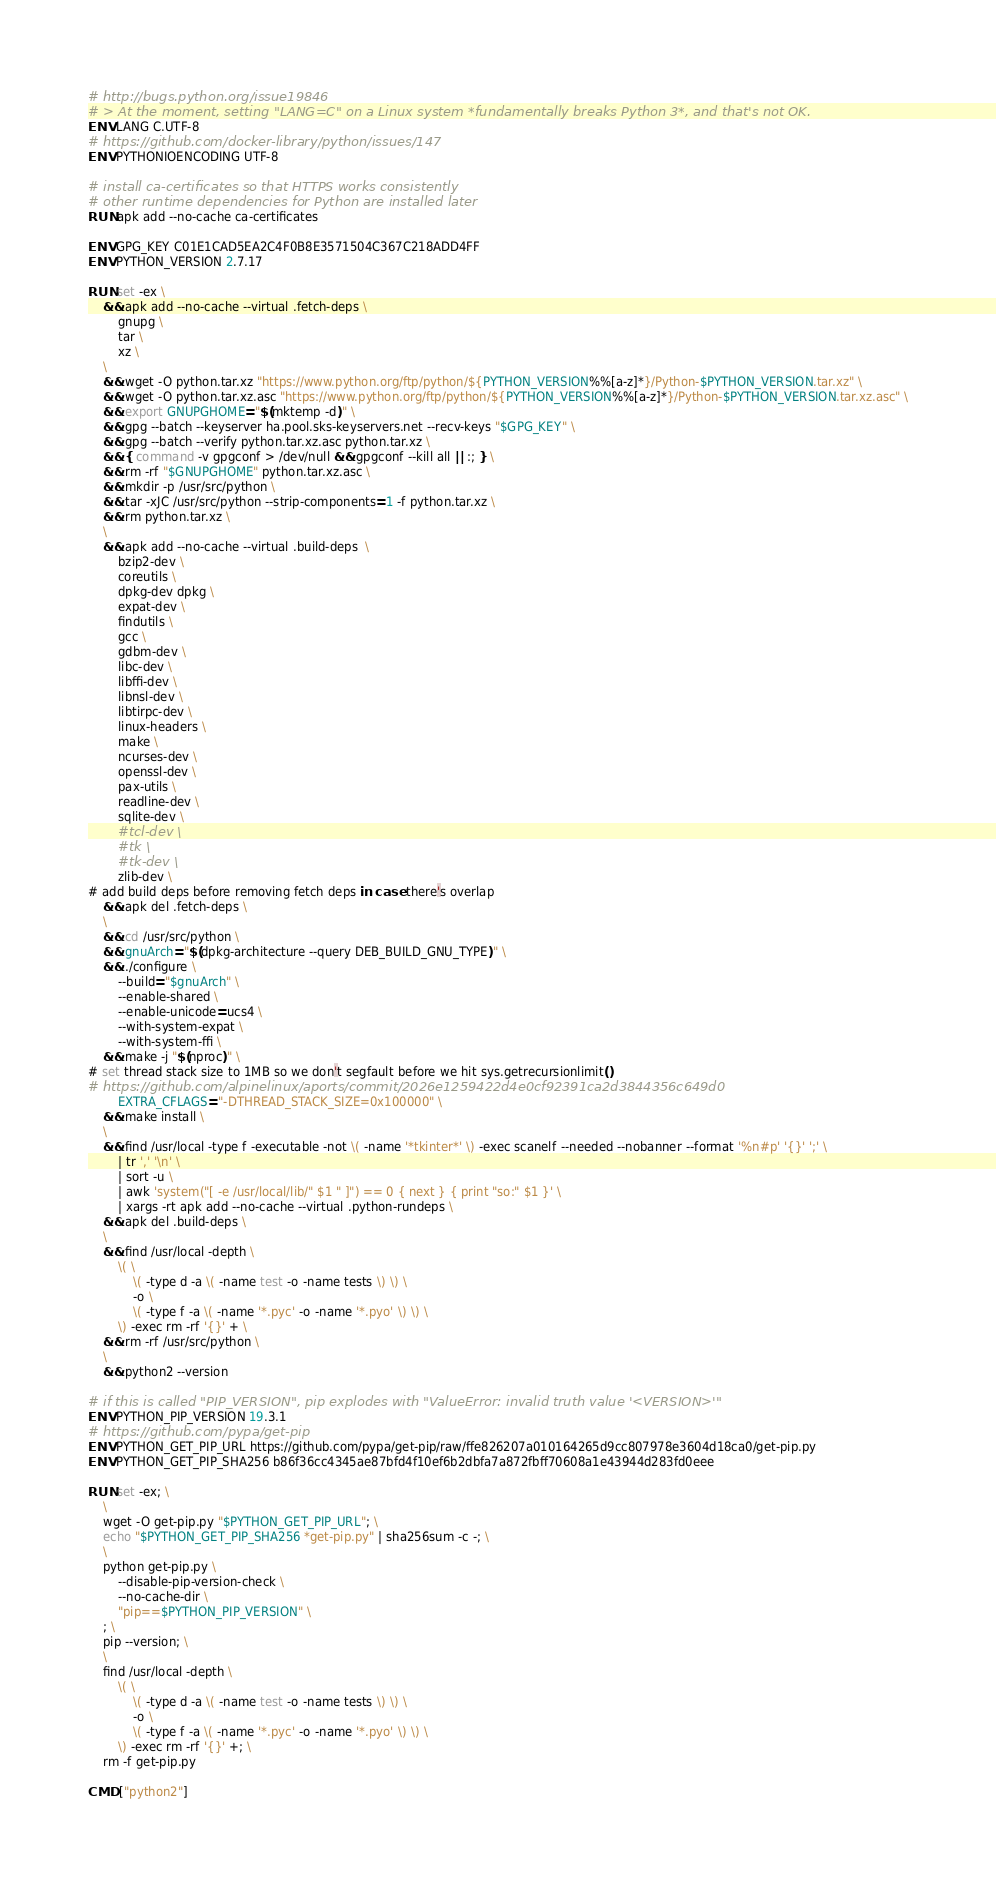<code> <loc_0><loc_0><loc_500><loc_500><_Dockerfile_># http://bugs.python.org/issue19846
# > At the moment, setting "LANG=C" on a Linux system *fundamentally breaks Python 3*, and that's not OK.
ENV LANG C.UTF-8
# https://github.com/docker-library/python/issues/147
ENV PYTHONIOENCODING UTF-8

# install ca-certificates so that HTTPS works consistently
# other runtime dependencies for Python are installed later
RUN apk add --no-cache ca-certificates

ENV GPG_KEY C01E1CAD5EA2C4F0B8E3571504C367C218ADD4FF
ENV PYTHON_VERSION 2.7.17

RUN set -ex \
	&& apk add --no-cache --virtual .fetch-deps \
		gnupg \
		tar \
		xz \
	\
	&& wget -O python.tar.xz "https://www.python.org/ftp/python/${PYTHON_VERSION%%[a-z]*}/Python-$PYTHON_VERSION.tar.xz" \
	&& wget -O python.tar.xz.asc "https://www.python.org/ftp/python/${PYTHON_VERSION%%[a-z]*}/Python-$PYTHON_VERSION.tar.xz.asc" \
	&& export GNUPGHOME="$(mktemp -d)" \
	&& gpg --batch --keyserver ha.pool.sks-keyservers.net --recv-keys "$GPG_KEY" \
	&& gpg --batch --verify python.tar.xz.asc python.tar.xz \
	&& { command -v gpgconf > /dev/null && gpgconf --kill all || :; } \
	&& rm -rf "$GNUPGHOME" python.tar.xz.asc \
	&& mkdir -p /usr/src/python \
	&& tar -xJC /usr/src/python --strip-components=1 -f python.tar.xz \
	&& rm python.tar.xz \
	\
	&& apk add --no-cache --virtual .build-deps  \
		bzip2-dev \
		coreutils \
		dpkg-dev dpkg \
		expat-dev \
		findutils \
		gcc \
		gdbm-dev \
		libc-dev \
		libffi-dev \
		libnsl-dev \
		libtirpc-dev \
		linux-headers \
		make \
		ncurses-dev \
		openssl-dev \
		pax-utils \
		readline-dev \
		sqlite-dev \
		#tcl-dev \
		#tk \
		#tk-dev \
		zlib-dev \
# add build deps before removing fetch deps in case there's overlap
	&& apk del .fetch-deps \
	\
	&& cd /usr/src/python \
	&& gnuArch="$(dpkg-architecture --query DEB_BUILD_GNU_TYPE)" \
	&& ./configure \
		--build="$gnuArch" \
		--enable-shared \
		--enable-unicode=ucs4 \
		--with-system-expat \
		--with-system-ffi \
	&& make -j "$(nproc)" \
# set thread stack size to 1MB so we don't segfault before we hit sys.getrecursionlimit()
# https://github.com/alpinelinux/aports/commit/2026e1259422d4e0cf92391ca2d3844356c649d0
		EXTRA_CFLAGS="-DTHREAD_STACK_SIZE=0x100000" \
	&& make install \
	\
	&& find /usr/local -type f -executable -not \( -name '*tkinter*' \) -exec scanelf --needed --nobanner --format '%n#p' '{}' ';' \
		| tr ',' '\n' \
		| sort -u \
		| awk 'system("[ -e /usr/local/lib/" $1 " ]") == 0 { next } { print "so:" $1 }' \
		| xargs -rt apk add --no-cache --virtual .python-rundeps \
	&& apk del .build-deps \
	\
	&& find /usr/local -depth \
		\( \
			\( -type d -a \( -name test -o -name tests \) \) \
			-o \
			\( -type f -a \( -name '*.pyc' -o -name '*.pyo' \) \) \
		\) -exec rm -rf '{}' + \
	&& rm -rf /usr/src/python \
	\
	&& python2 --version

# if this is called "PIP_VERSION", pip explodes with "ValueError: invalid truth value '<VERSION>'"
ENV PYTHON_PIP_VERSION 19.3.1
# https://github.com/pypa/get-pip
ENV PYTHON_GET_PIP_URL https://github.com/pypa/get-pip/raw/ffe826207a010164265d9cc807978e3604d18ca0/get-pip.py
ENV PYTHON_GET_PIP_SHA256 b86f36cc4345ae87bfd4f10ef6b2dbfa7a872fbff70608a1e43944d283fd0eee

RUN set -ex; \
	\
	wget -O get-pip.py "$PYTHON_GET_PIP_URL"; \
	echo "$PYTHON_GET_PIP_SHA256 *get-pip.py" | sha256sum -c -; \
	\
	python get-pip.py \
		--disable-pip-version-check \
		--no-cache-dir \
		"pip==$PYTHON_PIP_VERSION" \
	; \
	pip --version; \
	\
	find /usr/local -depth \
		\( \
			\( -type d -a \( -name test -o -name tests \) \) \
			-o \
			\( -type f -a \( -name '*.pyc' -o -name '*.pyo' \) \) \
		\) -exec rm -rf '{}' +; \
	rm -f get-pip.py

CMD ["python2"]
</code> 